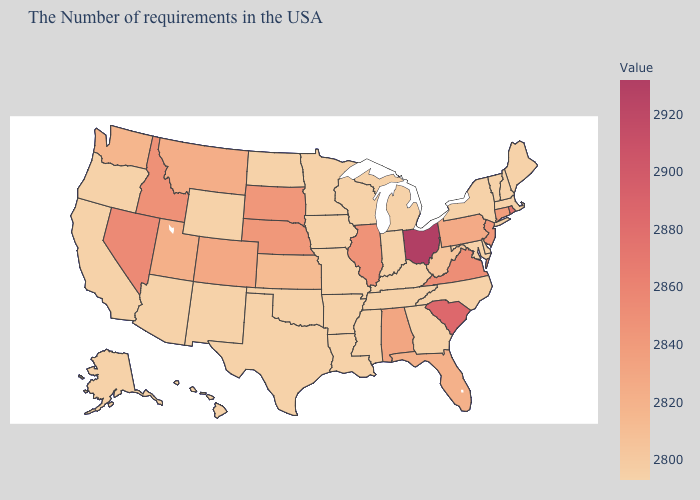Which states hav the highest value in the West?
Be succinct. Nevada. Does the map have missing data?
Write a very short answer. No. Does the map have missing data?
Quick response, please. No. Does Ohio have the highest value in the USA?
Write a very short answer. Yes. Is the legend a continuous bar?
Give a very brief answer. Yes. Does Washington have a lower value than South Carolina?
Give a very brief answer. Yes. 